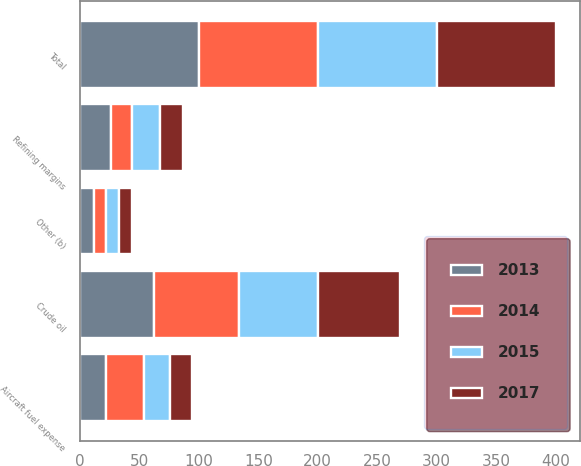Convert chart to OTSL. <chart><loc_0><loc_0><loc_500><loc_500><stacked_bar_chart><ecel><fcel>Crude oil<fcel>Refining margins<fcel>Other (b)<fcel>Total<fcel>Aircraft fuel expense<nl><fcel>2015<fcel>66<fcel>23<fcel>11<fcel>100<fcel>22<nl><fcel>2017<fcel>69<fcel>20<fcel>11<fcel>100<fcel>18<nl><fcel>2013<fcel>62<fcel>26<fcel>12<fcel>100<fcel>22<nl><fcel>2014<fcel>72<fcel>18<fcel>10<fcel>100<fcel>32<nl></chart> 